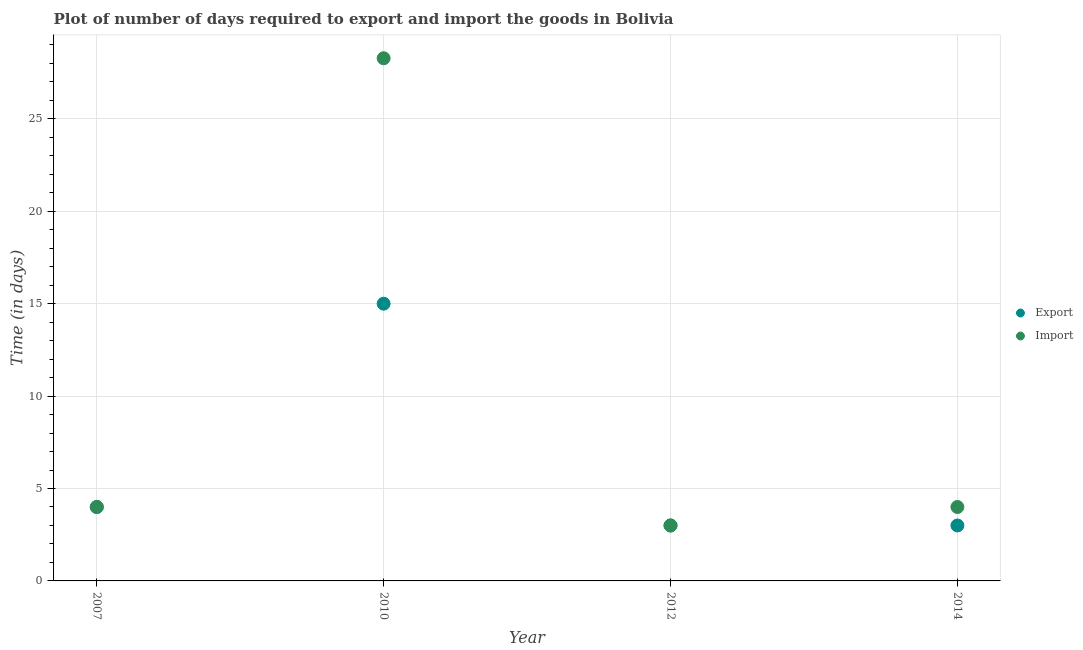How many different coloured dotlines are there?
Provide a succinct answer. 2. What is the time required to export in 2010?
Ensure brevity in your answer.  15. Across all years, what is the maximum time required to export?
Offer a very short reply. 15. What is the total time required to export in the graph?
Give a very brief answer. 25. What is the difference between the time required to import in 2010 and that in 2012?
Provide a short and direct response. 25.28. What is the average time required to export per year?
Ensure brevity in your answer.  6.25. What is the ratio of the time required to import in 2007 to that in 2010?
Your answer should be compact. 0.14. Is the difference between the time required to export in 2012 and 2014 greater than the difference between the time required to import in 2012 and 2014?
Give a very brief answer. Yes. What is the difference between the highest and the lowest time required to export?
Ensure brevity in your answer.  12. Does the time required to import monotonically increase over the years?
Offer a terse response. No. Is the time required to export strictly greater than the time required to import over the years?
Provide a short and direct response. No. Is the time required to import strictly less than the time required to export over the years?
Give a very brief answer. No. How many dotlines are there?
Your answer should be very brief. 2. How many years are there in the graph?
Offer a very short reply. 4. Does the graph contain any zero values?
Give a very brief answer. No. Does the graph contain grids?
Your answer should be compact. Yes. Where does the legend appear in the graph?
Make the answer very short. Center right. How many legend labels are there?
Your answer should be very brief. 2. What is the title of the graph?
Provide a succinct answer. Plot of number of days required to export and import the goods in Bolivia. What is the label or title of the X-axis?
Offer a terse response. Year. What is the label or title of the Y-axis?
Give a very brief answer. Time (in days). What is the Time (in days) of Export in 2010?
Your response must be concise. 15. What is the Time (in days) in Import in 2010?
Provide a short and direct response. 28.28. What is the Time (in days) of Export in 2012?
Give a very brief answer. 3. What is the Time (in days) of Export in 2014?
Give a very brief answer. 3. What is the Time (in days) of Import in 2014?
Make the answer very short. 4. Across all years, what is the maximum Time (in days) in Import?
Give a very brief answer. 28.28. Across all years, what is the minimum Time (in days) of Export?
Ensure brevity in your answer.  3. What is the total Time (in days) of Import in the graph?
Give a very brief answer. 39.28. What is the difference between the Time (in days) of Import in 2007 and that in 2010?
Keep it short and to the point. -24.28. What is the difference between the Time (in days) of Export in 2007 and that in 2014?
Make the answer very short. 1. What is the difference between the Time (in days) of Export in 2010 and that in 2012?
Provide a short and direct response. 12. What is the difference between the Time (in days) in Import in 2010 and that in 2012?
Offer a terse response. 25.28. What is the difference between the Time (in days) of Export in 2010 and that in 2014?
Give a very brief answer. 12. What is the difference between the Time (in days) of Import in 2010 and that in 2014?
Offer a terse response. 24.28. What is the difference between the Time (in days) in Export in 2012 and that in 2014?
Your answer should be very brief. 0. What is the difference between the Time (in days) in Import in 2012 and that in 2014?
Ensure brevity in your answer.  -1. What is the difference between the Time (in days) in Export in 2007 and the Time (in days) in Import in 2010?
Keep it short and to the point. -24.28. What is the difference between the Time (in days) of Export in 2007 and the Time (in days) of Import in 2012?
Offer a very short reply. 1. What is the difference between the Time (in days) in Export in 2010 and the Time (in days) in Import in 2014?
Provide a succinct answer. 11. What is the average Time (in days) in Export per year?
Your answer should be very brief. 6.25. What is the average Time (in days) in Import per year?
Provide a short and direct response. 9.82. In the year 2007, what is the difference between the Time (in days) of Export and Time (in days) of Import?
Your answer should be compact. 0. In the year 2010, what is the difference between the Time (in days) of Export and Time (in days) of Import?
Offer a very short reply. -13.28. In the year 2014, what is the difference between the Time (in days) of Export and Time (in days) of Import?
Provide a succinct answer. -1. What is the ratio of the Time (in days) of Export in 2007 to that in 2010?
Your answer should be very brief. 0.27. What is the ratio of the Time (in days) of Import in 2007 to that in 2010?
Provide a short and direct response. 0.14. What is the ratio of the Time (in days) of Import in 2007 to that in 2012?
Ensure brevity in your answer.  1.33. What is the ratio of the Time (in days) in Export in 2007 to that in 2014?
Offer a very short reply. 1.33. What is the ratio of the Time (in days) in Import in 2010 to that in 2012?
Ensure brevity in your answer.  9.43. What is the ratio of the Time (in days) in Import in 2010 to that in 2014?
Provide a succinct answer. 7.07. What is the ratio of the Time (in days) in Import in 2012 to that in 2014?
Ensure brevity in your answer.  0.75. What is the difference between the highest and the second highest Time (in days) of Import?
Provide a short and direct response. 24.28. What is the difference between the highest and the lowest Time (in days) in Import?
Offer a very short reply. 25.28. 